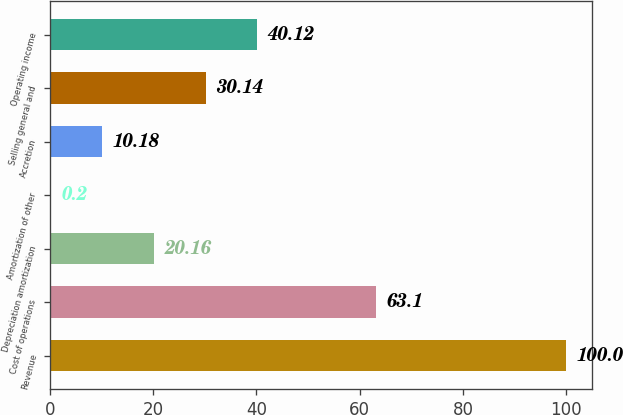Convert chart to OTSL. <chart><loc_0><loc_0><loc_500><loc_500><bar_chart><fcel>Revenue<fcel>Cost of operations<fcel>Depreciation amortization<fcel>Amortization of other<fcel>Accretion<fcel>Selling general and<fcel>Operating income<nl><fcel>100<fcel>63.1<fcel>20.16<fcel>0.2<fcel>10.18<fcel>30.14<fcel>40.12<nl></chart> 